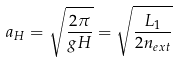Convert formula to latex. <formula><loc_0><loc_0><loc_500><loc_500>a _ { H } = \sqrt { \frac { 2 \pi } { g H } } = \sqrt { \frac { L _ { 1 } } { 2 n _ { e x t } } }</formula> 